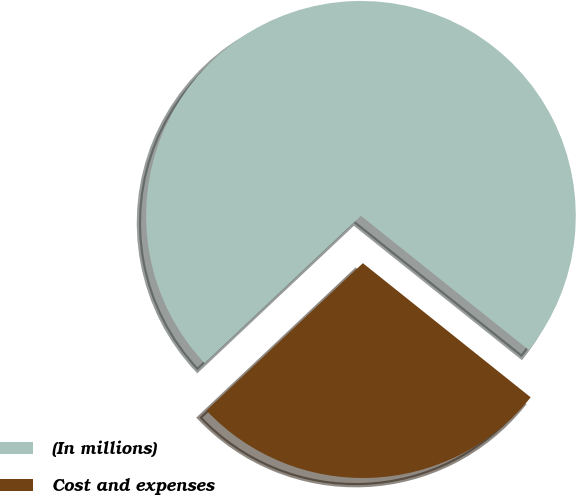<chart> <loc_0><loc_0><loc_500><loc_500><pie_chart><fcel>(In millions)<fcel>Cost and expenses<nl><fcel>72.76%<fcel>27.24%<nl></chart> 